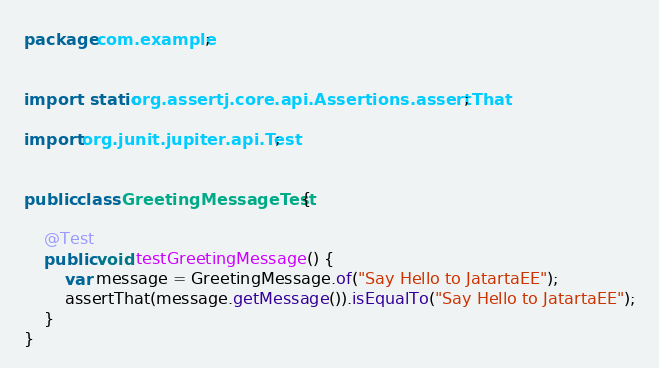<code> <loc_0><loc_0><loc_500><loc_500><_Java_>package com.example;


import static org.assertj.core.api.Assertions.assertThat;

import org.junit.jupiter.api.Test;


public class GreetingMessageTest {

    @Test
    public void testGreetingMessage() {
        var message = GreetingMessage.of("Say Hello to JatartaEE");
        assertThat(message.getMessage()).isEqualTo("Say Hello to JatartaEE");
    }
}
</code> 